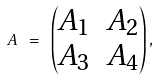Convert formula to latex. <formula><loc_0><loc_0><loc_500><loc_500>A \ = \ \begin{pmatrix} A _ { 1 } & A _ { 2 } \\ A _ { 3 } & A _ { 4 } \end{pmatrix} ,</formula> 